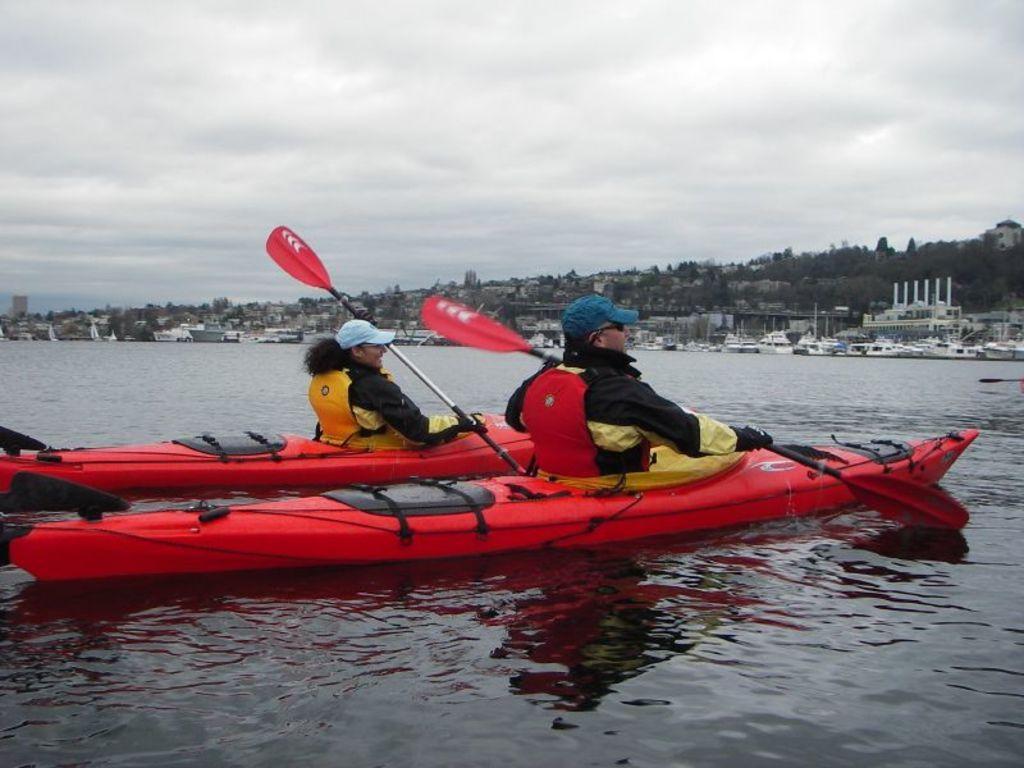Please provide a concise description of this image. In this picture there are two persons sitting on the boats and holding the objects. At the back there are buildings and trees and there are boats on the water. At the top there is sky. At the bottom there is water. 